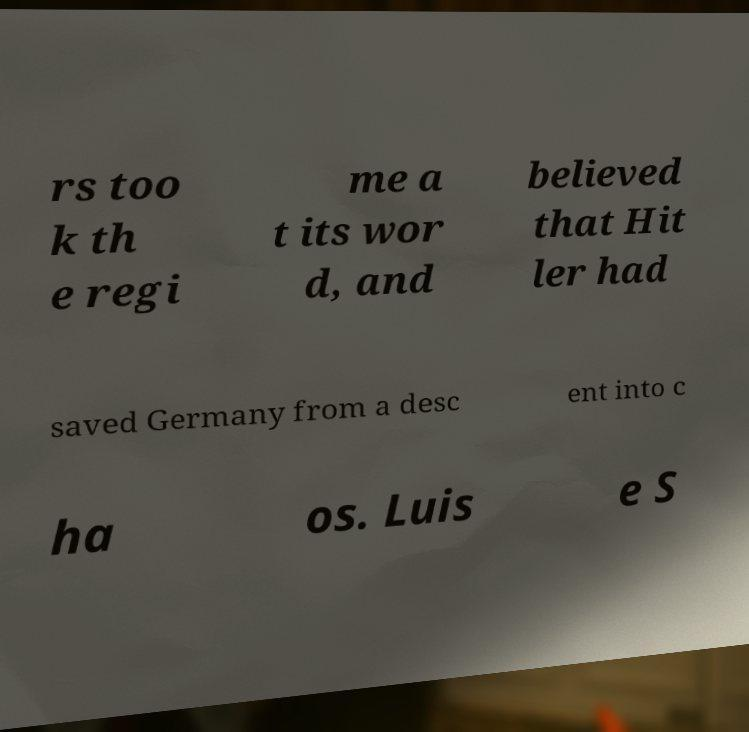Could you extract and type out the text from this image? rs too k th e regi me a t its wor d, and believed that Hit ler had saved Germany from a desc ent into c ha os. Luis e S 